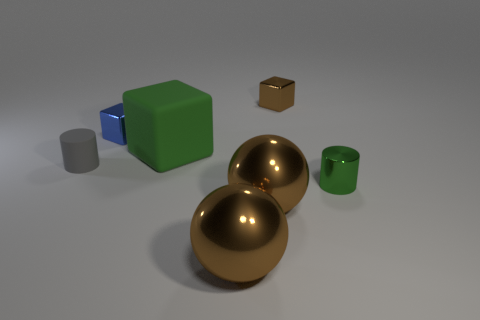Add 3 brown metal blocks. How many objects exist? 10 Subtract all small metal blocks. How many blocks are left? 1 Subtract 1 cubes. How many cubes are left? 2 Subtract all gray cylinders. How many cylinders are left? 1 Subtract all cubes. How many objects are left? 4 Subtract all yellow balls. Subtract all brown cylinders. How many balls are left? 2 Subtract all gray rubber objects. Subtract all metallic balls. How many objects are left? 4 Add 1 big rubber things. How many big rubber things are left? 2 Add 4 small purple metal cubes. How many small purple metal cubes exist? 4 Subtract 0 blue cylinders. How many objects are left? 7 